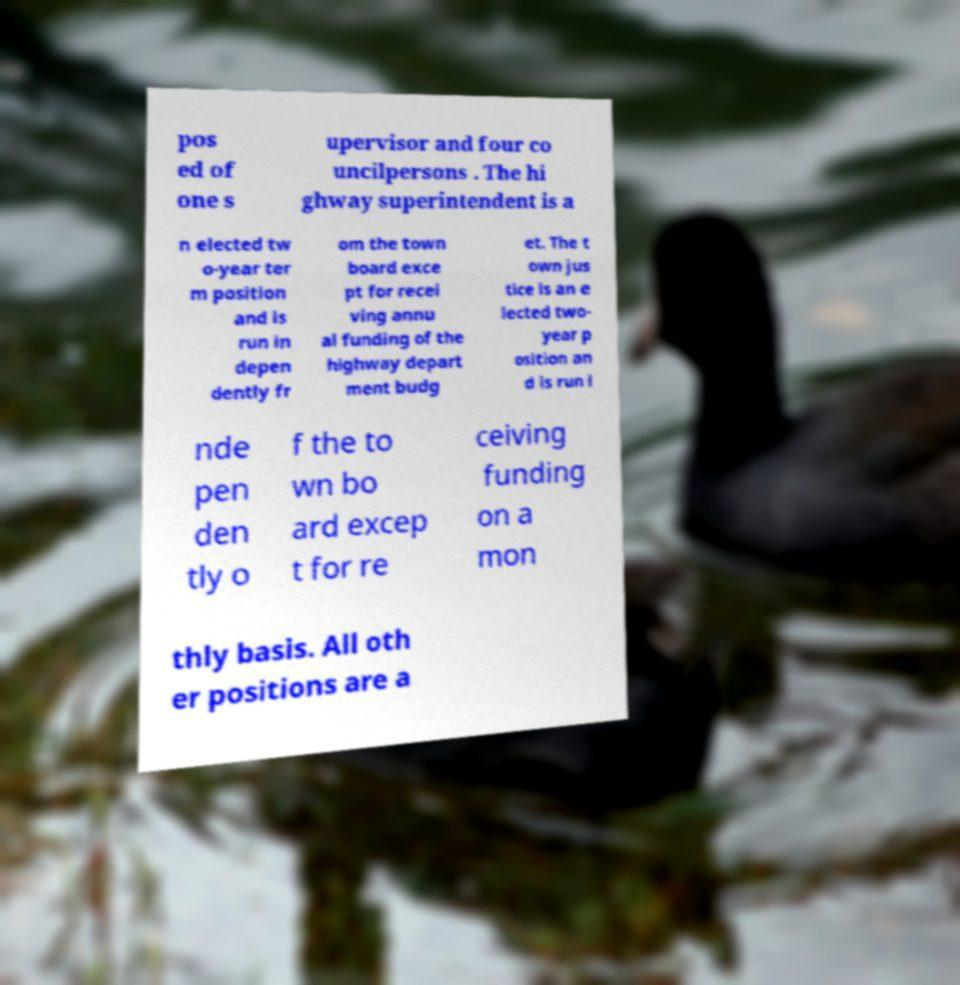Please read and relay the text visible in this image. What does it say? pos ed of one s upervisor and four co uncilpersons . The hi ghway superintendent is a n elected tw o-year ter m position and is run in depen dently fr om the town board exce pt for recei ving annu al funding of the highway depart ment budg et. The t own jus tice is an e lected two- year p osition an d is run i nde pen den tly o f the to wn bo ard excep t for re ceiving funding on a mon thly basis. All oth er positions are a 